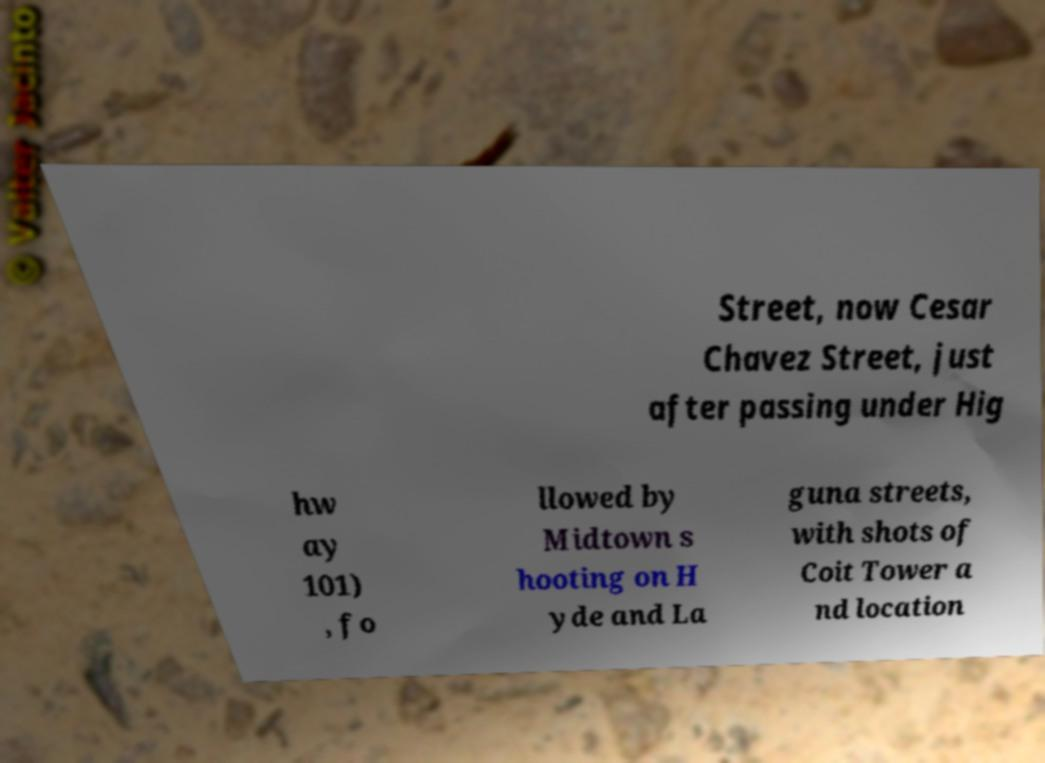Please read and relay the text visible in this image. What does it say? Street, now Cesar Chavez Street, just after passing under Hig hw ay 101) , fo llowed by Midtown s hooting on H yde and La guna streets, with shots of Coit Tower a nd location 